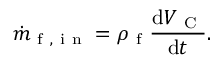<formula> <loc_0><loc_0><loc_500><loc_500>\dot { m } _ { f , i n } = \rho _ { f } \frac { d V _ { C } } { d t } .</formula> 